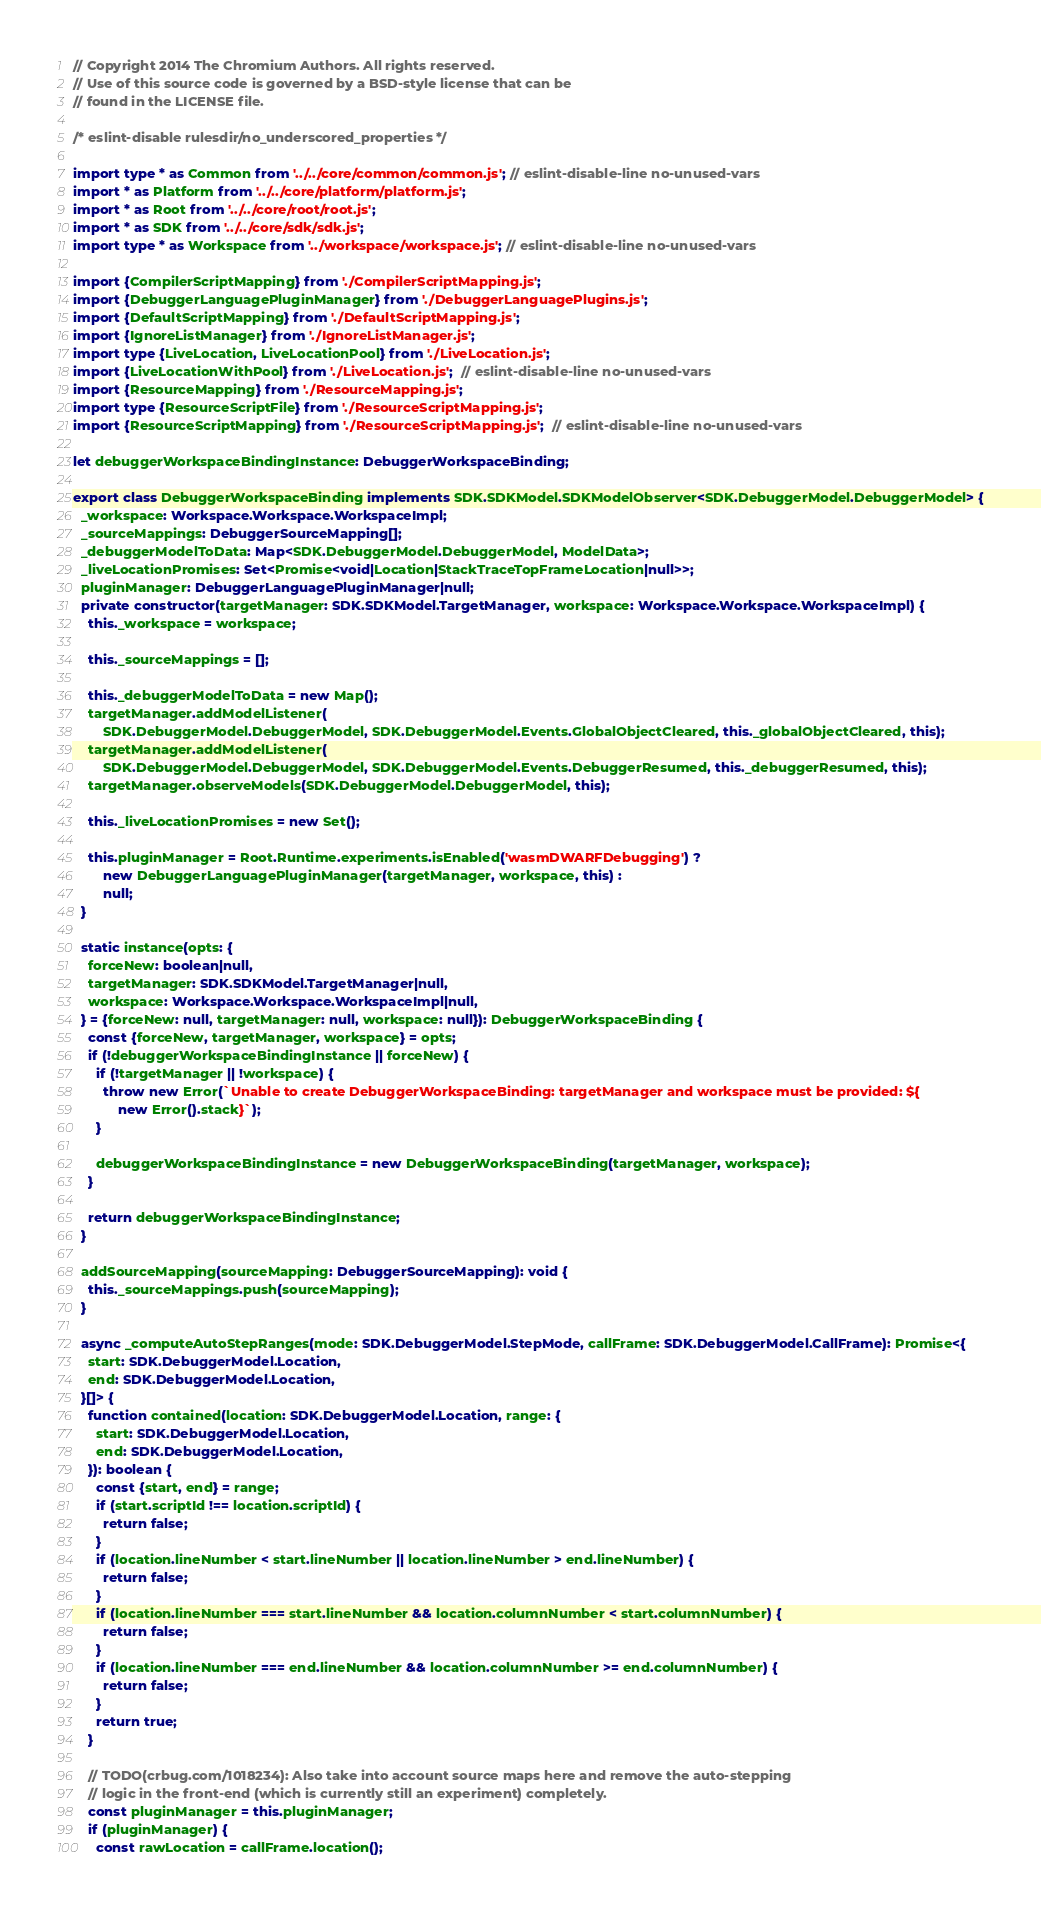Convert code to text. <code><loc_0><loc_0><loc_500><loc_500><_TypeScript_>// Copyright 2014 The Chromium Authors. All rights reserved.
// Use of this source code is governed by a BSD-style license that can be
// found in the LICENSE file.

/* eslint-disable rulesdir/no_underscored_properties */

import type * as Common from '../../core/common/common.js'; // eslint-disable-line no-unused-vars
import * as Platform from '../../core/platform/platform.js';
import * as Root from '../../core/root/root.js';
import * as SDK from '../../core/sdk/sdk.js';
import type * as Workspace from '../workspace/workspace.js'; // eslint-disable-line no-unused-vars

import {CompilerScriptMapping} from './CompilerScriptMapping.js';
import {DebuggerLanguagePluginManager} from './DebuggerLanguagePlugins.js';
import {DefaultScriptMapping} from './DefaultScriptMapping.js';
import {IgnoreListManager} from './IgnoreListManager.js';
import type {LiveLocation, LiveLocationPool} from './LiveLocation.js';
import {LiveLocationWithPool} from './LiveLocation.js';  // eslint-disable-line no-unused-vars
import {ResourceMapping} from './ResourceMapping.js';
import type {ResourceScriptFile} from './ResourceScriptMapping.js';
import {ResourceScriptMapping} from './ResourceScriptMapping.js';  // eslint-disable-line no-unused-vars

let debuggerWorkspaceBindingInstance: DebuggerWorkspaceBinding;

export class DebuggerWorkspaceBinding implements SDK.SDKModel.SDKModelObserver<SDK.DebuggerModel.DebuggerModel> {
  _workspace: Workspace.Workspace.WorkspaceImpl;
  _sourceMappings: DebuggerSourceMapping[];
  _debuggerModelToData: Map<SDK.DebuggerModel.DebuggerModel, ModelData>;
  _liveLocationPromises: Set<Promise<void|Location|StackTraceTopFrameLocation|null>>;
  pluginManager: DebuggerLanguagePluginManager|null;
  private constructor(targetManager: SDK.SDKModel.TargetManager, workspace: Workspace.Workspace.WorkspaceImpl) {
    this._workspace = workspace;

    this._sourceMappings = [];

    this._debuggerModelToData = new Map();
    targetManager.addModelListener(
        SDK.DebuggerModel.DebuggerModel, SDK.DebuggerModel.Events.GlobalObjectCleared, this._globalObjectCleared, this);
    targetManager.addModelListener(
        SDK.DebuggerModel.DebuggerModel, SDK.DebuggerModel.Events.DebuggerResumed, this._debuggerResumed, this);
    targetManager.observeModels(SDK.DebuggerModel.DebuggerModel, this);

    this._liveLocationPromises = new Set();

    this.pluginManager = Root.Runtime.experiments.isEnabled('wasmDWARFDebugging') ?
        new DebuggerLanguagePluginManager(targetManager, workspace, this) :
        null;
  }

  static instance(opts: {
    forceNew: boolean|null,
    targetManager: SDK.SDKModel.TargetManager|null,
    workspace: Workspace.Workspace.WorkspaceImpl|null,
  } = {forceNew: null, targetManager: null, workspace: null}): DebuggerWorkspaceBinding {
    const {forceNew, targetManager, workspace} = opts;
    if (!debuggerWorkspaceBindingInstance || forceNew) {
      if (!targetManager || !workspace) {
        throw new Error(`Unable to create DebuggerWorkspaceBinding: targetManager and workspace must be provided: ${
            new Error().stack}`);
      }

      debuggerWorkspaceBindingInstance = new DebuggerWorkspaceBinding(targetManager, workspace);
    }

    return debuggerWorkspaceBindingInstance;
  }

  addSourceMapping(sourceMapping: DebuggerSourceMapping): void {
    this._sourceMappings.push(sourceMapping);
  }

  async _computeAutoStepRanges(mode: SDK.DebuggerModel.StepMode, callFrame: SDK.DebuggerModel.CallFrame): Promise<{
    start: SDK.DebuggerModel.Location,
    end: SDK.DebuggerModel.Location,
  }[]> {
    function contained(location: SDK.DebuggerModel.Location, range: {
      start: SDK.DebuggerModel.Location,
      end: SDK.DebuggerModel.Location,
    }): boolean {
      const {start, end} = range;
      if (start.scriptId !== location.scriptId) {
        return false;
      }
      if (location.lineNumber < start.lineNumber || location.lineNumber > end.lineNumber) {
        return false;
      }
      if (location.lineNumber === start.lineNumber && location.columnNumber < start.columnNumber) {
        return false;
      }
      if (location.lineNumber === end.lineNumber && location.columnNumber >= end.columnNumber) {
        return false;
      }
      return true;
    }

    // TODO(crbug.com/1018234): Also take into account source maps here and remove the auto-stepping
    // logic in the front-end (which is currently still an experiment) completely.
    const pluginManager = this.pluginManager;
    if (pluginManager) {
      const rawLocation = callFrame.location();</code> 